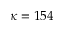Convert formula to latex. <formula><loc_0><loc_0><loc_500><loc_500>\kappa = 1 5 4</formula> 